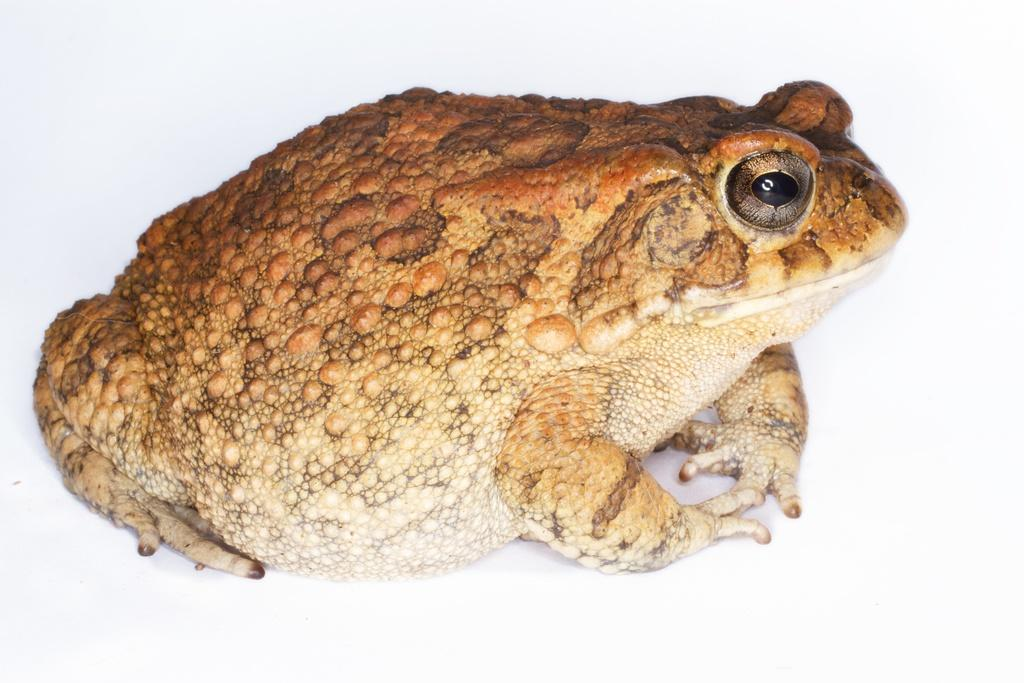What is the main subject of the picture? The main subject of the picture is a frog. Can you describe the appearance of the frog? The frog is brown and white in color. What color is the background of the image? The background of the image is white. What type of experience does the frog have with expansion? There is no indication in the image that the frog has any experience with expansion, as the image only shows the frog's appearance and color. 